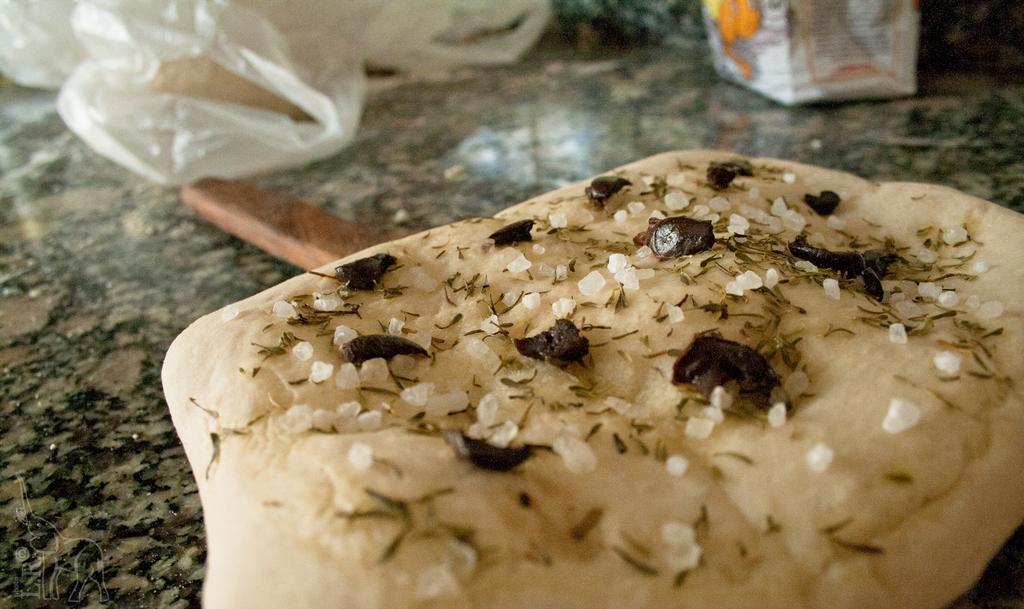Please provide a concise description of this image. In this image we can see a food item, there is a wooden stick, there are covers, and a box, which all are on the granite. 